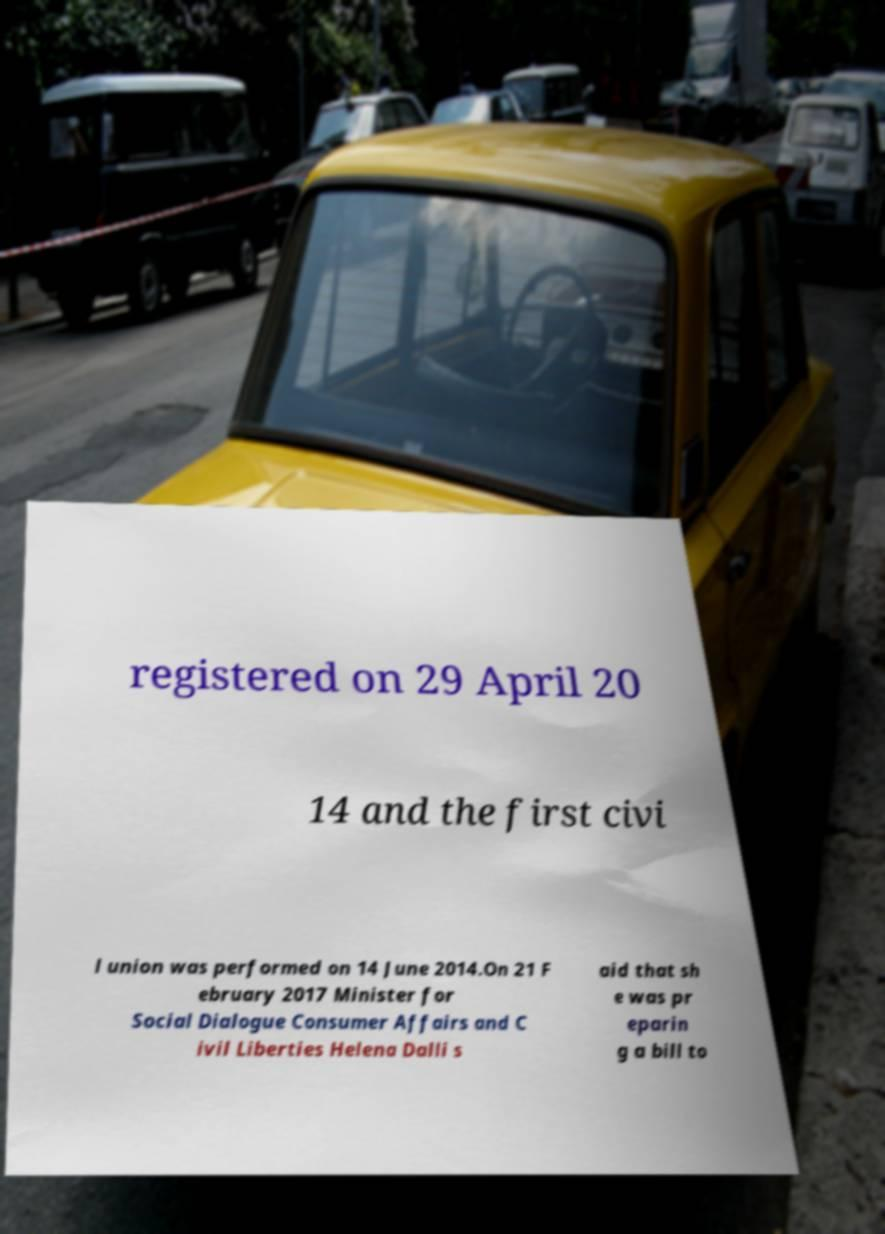Please identify and transcribe the text found in this image. registered on 29 April 20 14 and the first civi l union was performed on 14 June 2014.On 21 F ebruary 2017 Minister for Social Dialogue Consumer Affairs and C ivil Liberties Helena Dalli s aid that sh e was pr eparin g a bill to 